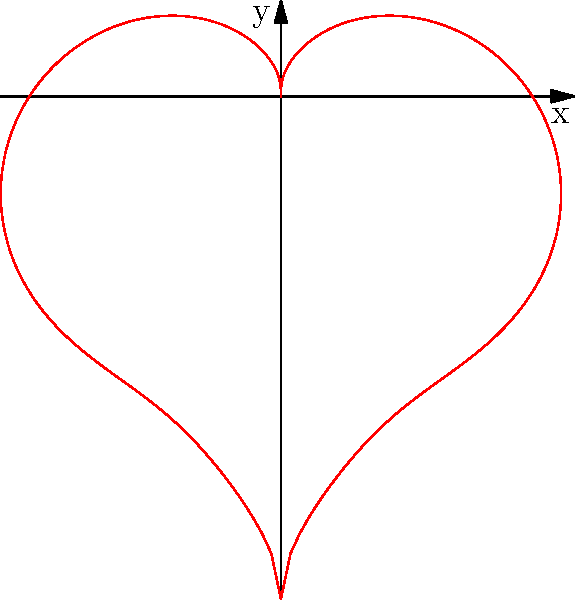In the realm of poetic geometry, a heart-shaped curve can be represented by the polar equation:

$$r = 2 - 2\sin(\theta) + \frac{\sin(\theta)\sqrt{|\cos(\theta)|}}{\sin(\theta)+1.4}$$

What aspect of this equation creates the characteristic "dip" at the top of the heart, reminiscent of the emotional depth often explored in love poetry? To understand the creation of the "dip" in the heart-shaped curve, let's analyze the equation step-by-step:

1) The basic equation $r = 2 - 2\sin(\theta)$ would create a cardioid shape, which is heart-like but lacks the distinctive dip at the top.

2) The additional term $\frac{\sin(\theta)\sqrt{|\cos(\theta)|}}{\sin(\theta)+1.4}$ is responsible for modifying the cardioid to create the dip.

3) When $\theta$ is close to $\frac{\pi}{2}$ (top of the heart):
   - $\sin(\theta)$ is close to 1
   - $\cos(\theta)$ is close to 0
   - $\sqrt{|\cos(\theta)|}$ becomes very small

4) This causes the fraction $\frac{\sin(\theta)\sqrt{|\cos(\theta)|}}{\sin(\theta)+1.4}$ to approach 0 at the top of the heart.

5) As a result, $r$ becomes smaller at this point, creating the characteristic dip.

6) The term $\sin(\theta)+1.4$ in the denominator ensures that the fraction doesn't become undefined when $\sin(\theta)$ is -1.

The dip in the heart shape is thus created by the subtle interplay of trigonometric functions, much like how the emotional depth in love poetry often emerges from the intricate interplay of rhythm, meter, and imagery.
Answer: The term $\frac{\sin(\theta)\sqrt{|\cos(\theta)|}}{\sin(\theta)+1.4}$ 